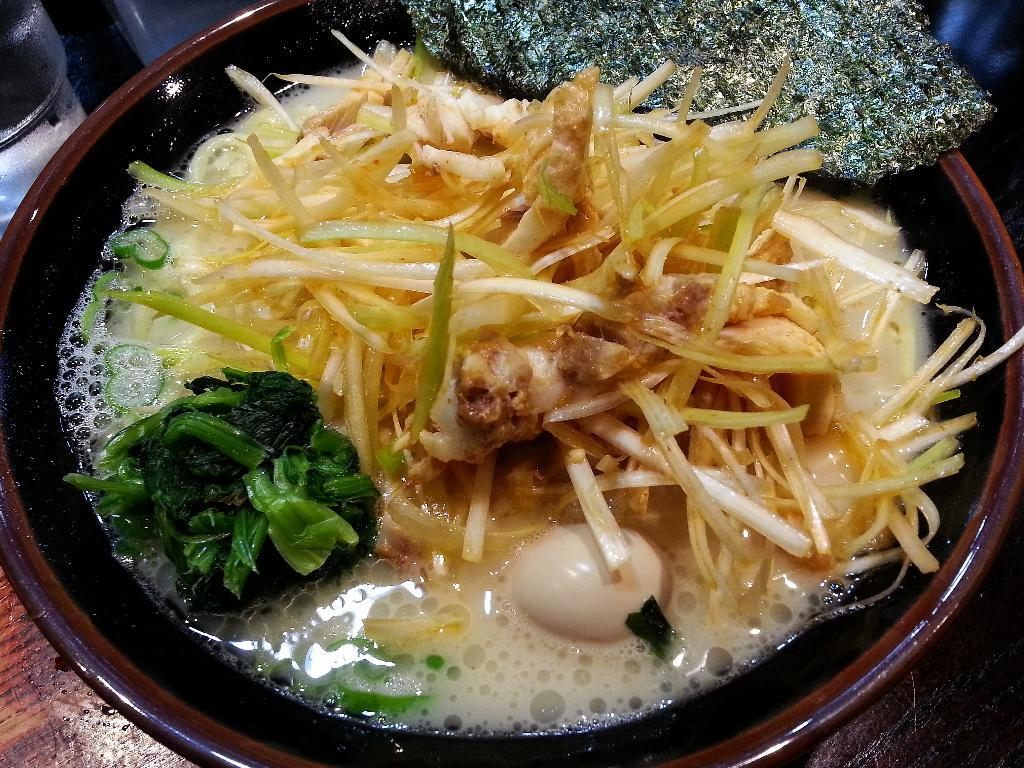What is in the bowl that is visible in the image? There is food in a bowl in the image. What type of learning is taking place in the image? There is no indication of any learning taking place in the image; it simply shows food in a bowl. What type of cabbage is present in the image? There is no cabbage present in the image; it only shows food in a bowl. 